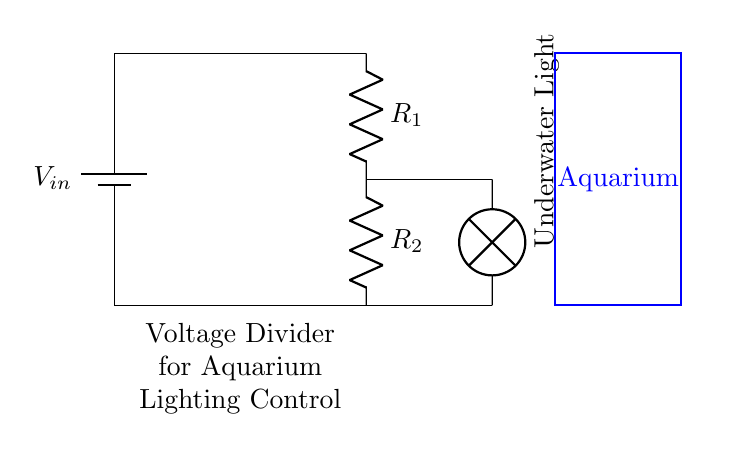What type of circuit is represented here? This circuit is a voltage divider, which is specifically designed to reduce voltage across certain components in a circuit. The arrangement of resistors reflects this purpose, where the input voltage is divided to control the output voltage.
Answer: Voltage Divider What components are present in this circuit? The components visible in the circuit diagram include a battery, two resistors, and a lamp. The battery provides input voltage, the resistors create the voltage division, and the lamp acts as the load that consumes power from the circuit.
Answer: Battery, Resistors, Lamp What is the purpose of resistors in this circuit? The resistors in a voltage divider are used to set the voltage levels that drop across them. By adjusting the resistor values, you can control how much voltage is supplied to the lamp, thereby controlling its brightness in the aquarium lighting setup.
Answer: Control voltage drop What is the role of the underwater light? The underwater light serves as the load of the electrical circuit. It receives voltage from the resistors and illuminates, providing light for the aquatic environment in the aquarium. Its brightness depends on the voltage it receives.
Answer: Load for illumination How does the arrangement of resistors affect the voltage? The voltage is divided amongst the resistors based on their resistances according to the voltage divider formula. The output voltage can be calculated by knowing the input voltage and the resistor values, which determines how brightly the lamp will shine.
Answer: Divides voltage If the value of R1 is greater than R2, what happens to the brightness of the lamp? If R1 is greater than R2, more voltage will drop across R1 compared to R2, resulting in a lower voltage across the lamp. Consequently, the lamp will be dimmer since it receives less power.
Answer: Lamp dims 